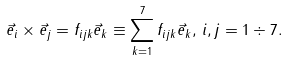Convert formula to latex. <formula><loc_0><loc_0><loc_500><loc_500>\vec { e } _ { i } \times \vec { e } _ { j } = f _ { i j k } \vec { e } _ { k } \equiv \sum _ { k = 1 } ^ { 7 } f _ { i j k } \vec { e } _ { k } , \, i , j = 1 \div 7 .</formula> 